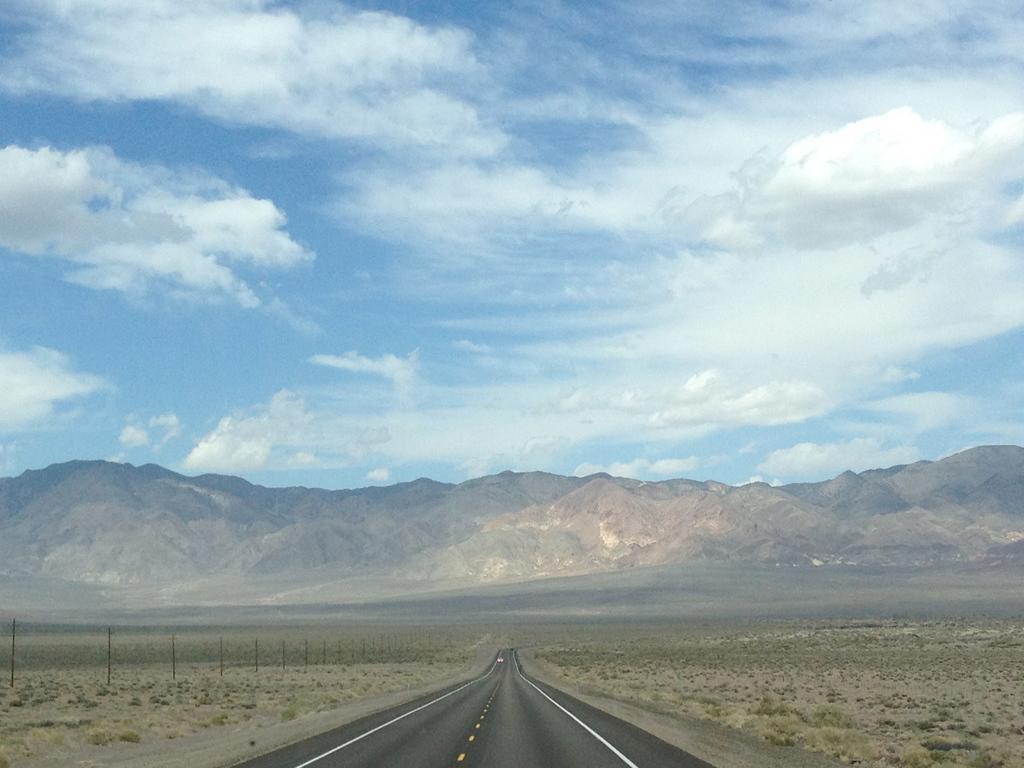How would you summarize this image in a sentence or two? In this picture in the center there is a road and on the left side there are poles. In the background there are mountains and the sky is cloudy. 